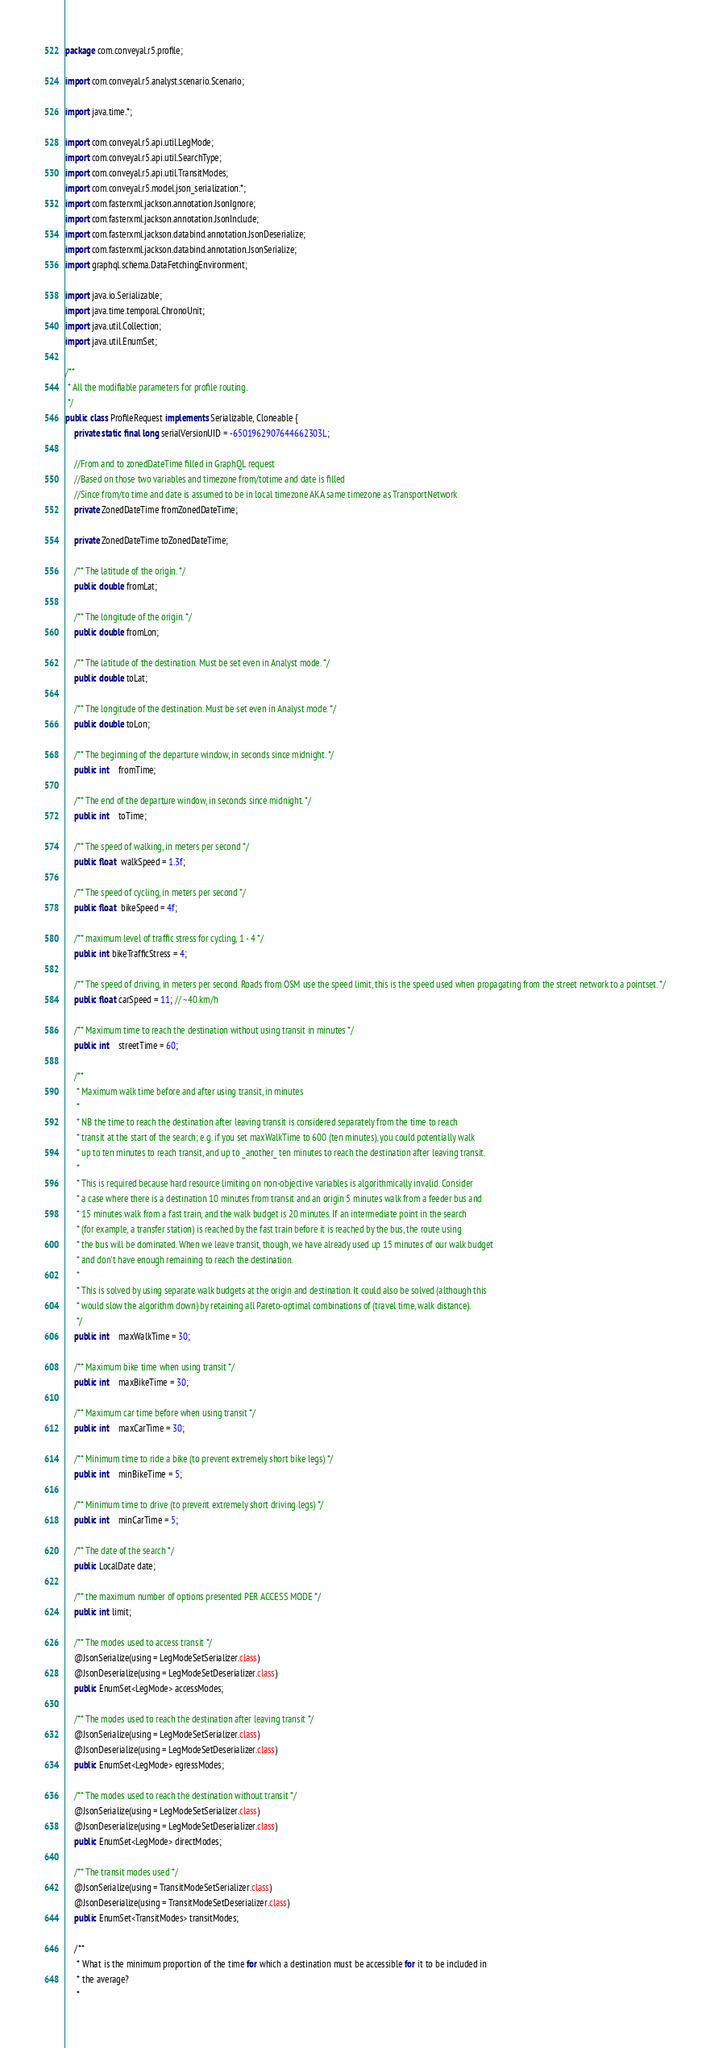Convert code to text. <code><loc_0><loc_0><loc_500><loc_500><_Java_>package com.conveyal.r5.profile;

import com.conveyal.r5.analyst.scenario.Scenario;

import java.time.*;

import com.conveyal.r5.api.util.LegMode;
import com.conveyal.r5.api.util.SearchType;
import com.conveyal.r5.api.util.TransitModes;
import com.conveyal.r5.model.json_serialization.*;
import com.fasterxml.jackson.annotation.JsonIgnore;
import com.fasterxml.jackson.annotation.JsonInclude;
import com.fasterxml.jackson.databind.annotation.JsonDeserialize;
import com.fasterxml.jackson.databind.annotation.JsonSerialize;
import graphql.schema.DataFetchingEnvironment;

import java.io.Serializable;
import java.time.temporal.ChronoUnit;
import java.util.Collection;
import java.util.EnumSet;

/**
 * All the modifiable parameters for profile routing.
 */
public class ProfileRequest implements Serializable, Cloneable {
    private static final long serialVersionUID = -6501962907644662303L;

    //From and to zonedDateTime filled in GraphQL request
    //Based on those two variables and timezone from/totime and date is filled
    //Since from/to time and date is assumed to be in local timezone AKA same timezone as TransportNetwork
    private ZonedDateTime fromZonedDateTime;

    private ZonedDateTime toZonedDateTime;

    /** The latitude of the origin. */
    public double fromLat;
    
    /** The longitude of the origin. */
    public double fromLon;
    
    /** The latitude of the destination. Must be set even in Analyst mode. */
    public double toLat;
    
    /** The longitude of the destination. Must be set even in Analyst mode. */
    public double toLon;
    
    /** The beginning of the departure window, in seconds since midnight. */
    public int    fromTime;
    
    /** The end of the departure window, in seconds since midnight. */
    public int    toTime;

    /** The speed of walking, in meters per second */
    public float  walkSpeed = 1.3f;
    
    /** The speed of cycling, in meters per second */
    public float  bikeSpeed = 4f;

    /** maximum level of traffic stress for cycling, 1 - 4 */
    public int bikeTrafficStress = 4;
    
    /** The speed of driving, in meters per second. Roads from OSM use the speed limit, this is the speed used when propagating from the street network to a pointset. */
    public float carSpeed = 11; // ~40 km/h

    /** Maximum time to reach the destination without using transit in minutes */
    public int    streetTime = 60;
    
    /**
     * Maximum walk time before and after using transit, in minutes
     *
     * NB the time to reach the destination after leaving transit is considered separately from the time to reach
     * transit at the start of the search; e.g. if you set maxWalkTime to 600 (ten minutes), you could potentially walk
     * up to ten minutes to reach transit, and up to _another_ ten minutes to reach the destination after leaving transit.
     *
     * This is required because hard resource limiting on non-objective variables is algorithmically invalid. Consider
     * a case where there is a destination 10 minutes from transit and an origin 5 minutes walk from a feeder bus and
     * 15 minutes walk from a fast train, and the walk budget is 20 minutes. If an intermediate point in the search
     * (for example, a transfer station) is reached by the fast train before it is reached by the bus, the route using
     * the bus will be dominated. When we leave transit, though, we have already used up 15 minutes of our walk budget
     * and don't have enough remaining to reach the destination.
     *
     * This is solved by using separate walk budgets at the origin and destination. It could also be solved (although this
     * would slow the algorithm down) by retaining all Pareto-optimal combinations of (travel time, walk distance).
     */
    public int    maxWalkTime = 30;
    
    /** Maximum bike time when using transit */
    public int    maxBikeTime = 30;
    
    /** Maximum car time before when using transit */ 
    public int    maxCarTime = 30;
    
    /** Minimum time to ride a bike (to prevent extremely short bike legs) */
    public int    minBikeTime = 5;
    
    /** Minimum time to drive (to prevent extremely short driving legs) */
    public int    minCarTime = 5;

    /** The date of the search */
    public LocalDate date;
    
    /** the maximum number of options presented PER ACCESS MODE */
    public int limit;
    
    /** The modes used to access transit */
    @JsonSerialize(using = LegModeSetSerializer.class)
    @JsonDeserialize(using = LegModeSetDeserializer.class)
    public EnumSet<LegMode> accessModes;
    
    /** The modes used to reach the destination after leaving transit */
    @JsonSerialize(using = LegModeSetSerializer.class)
    @JsonDeserialize(using = LegModeSetDeserializer.class)
    public EnumSet<LegMode> egressModes;
    
    /** The modes used to reach the destination without transit */
    @JsonSerialize(using = LegModeSetSerializer.class)
    @JsonDeserialize(using = LegModeSetDeserializer.class)
    public EnumSet<LegMode> directModes;
    
    /** The transit modes used */
    @JsonSerialize(using = TransitModeSetSerializer.class)
    @JsonDeserialize(using = TransitModeSetDeserializer.class)
    public EnumSet<TransitModes> transitModes;

    /**
     * What is the minimum proportion of the time for which a destination must be accessible for it to be included in
     * the average?
     *</code> 